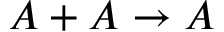Convert formula to latex. <formula><loc_0><loc_0><loc_500><loc_500>A + A \rightarrow A</formula> 